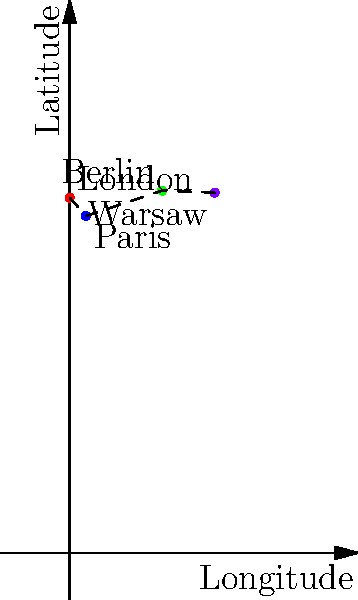A new cognitive-behavioral therapy approach for treating anxiety disorders has been introduced in London. The approach is spreading across Europe, with major cities adopting it in the following order: London, Paris, Berlin, and Warsaw. Using the coordinate system provided, calculate the total distance traveled by this therapeutic approach (in degrees) as it spreads from city to city. To solve this problem, we need to follow these steps:

1. Identify the coordinates of each city:
   London: (0°, 51.5°)
   Paris: (2.35°, 48.85°)
   Berlin: (13.4°, 52.52°)
   Warsaw: (21.01°, 52.23°)

2. Calculate the distance between each consecutive pair of cities using the distance formula:
   $d = \sqrt{(x_2 - x_1)^2 + (y_2 - y_1)^2}$

3. London to Paris:
   $d_1 = \sqrt{(2.35 - 0)^2 + (48.85 - 51.5)^2} = 3.44°$

4. Paris to Berlin:
   $d_2 = \sqrt{(13.4 - 2.35)^2 + (52.52 - 48.85)^2} = 11.65°$

5. Berlin to Warsaw:
   $d_3 = \sqrt{(21.01 - 13.4)^2 + (52.23 - 52.52)^2} = 7.61°$

6. Sum up all the distances:
   Total distance = $d_1 + d_2 + d_3 = 3.44° + 11.65° + 7.61° = 22.70°$
Answer: 22.70° 